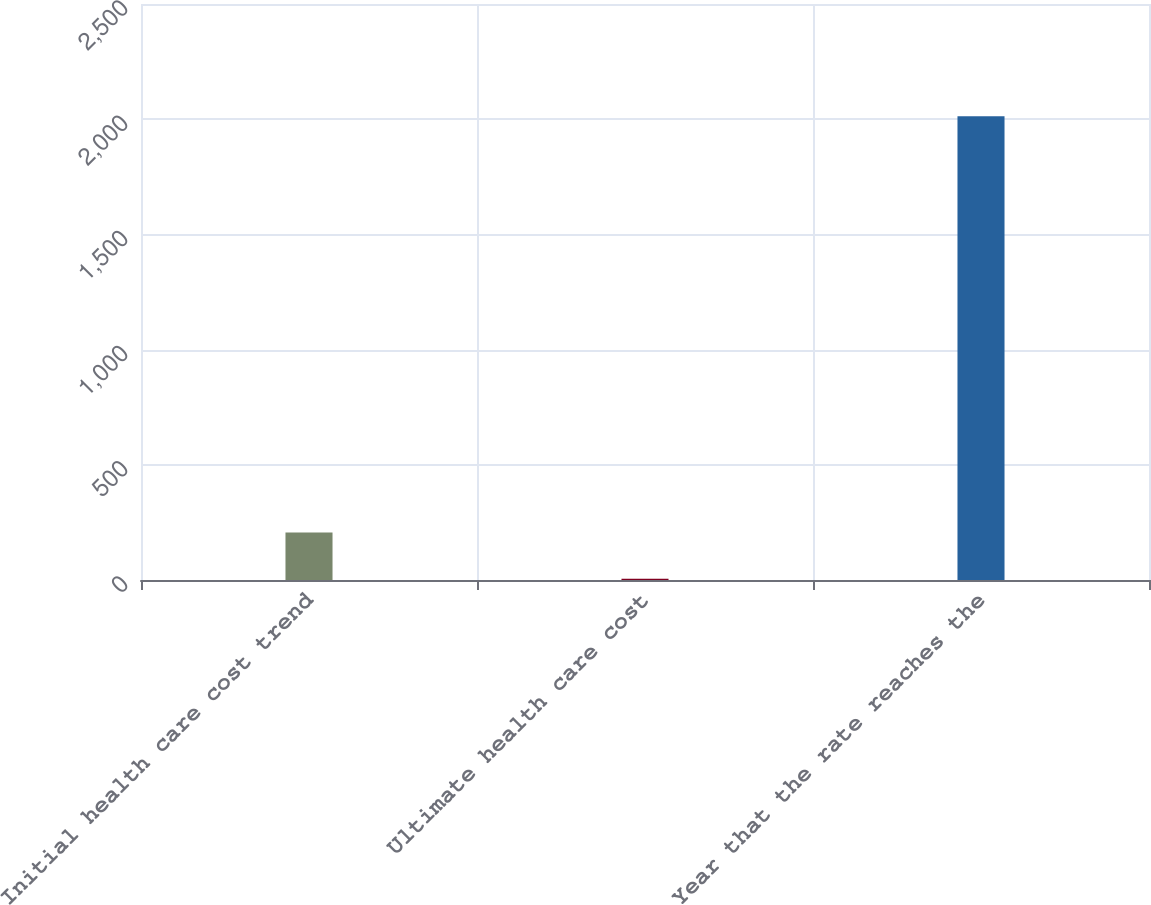Convert chart. <chart><loc_0><loc_0><loc_500><loc_500><bar_chart><fcel>Initial health care cost trend<fcel>Ultimate health care cost<fcel>Year that the rate reaches the<nl><fcel>206.25<fcel>5.5<fcel>2013<nl></chart> 